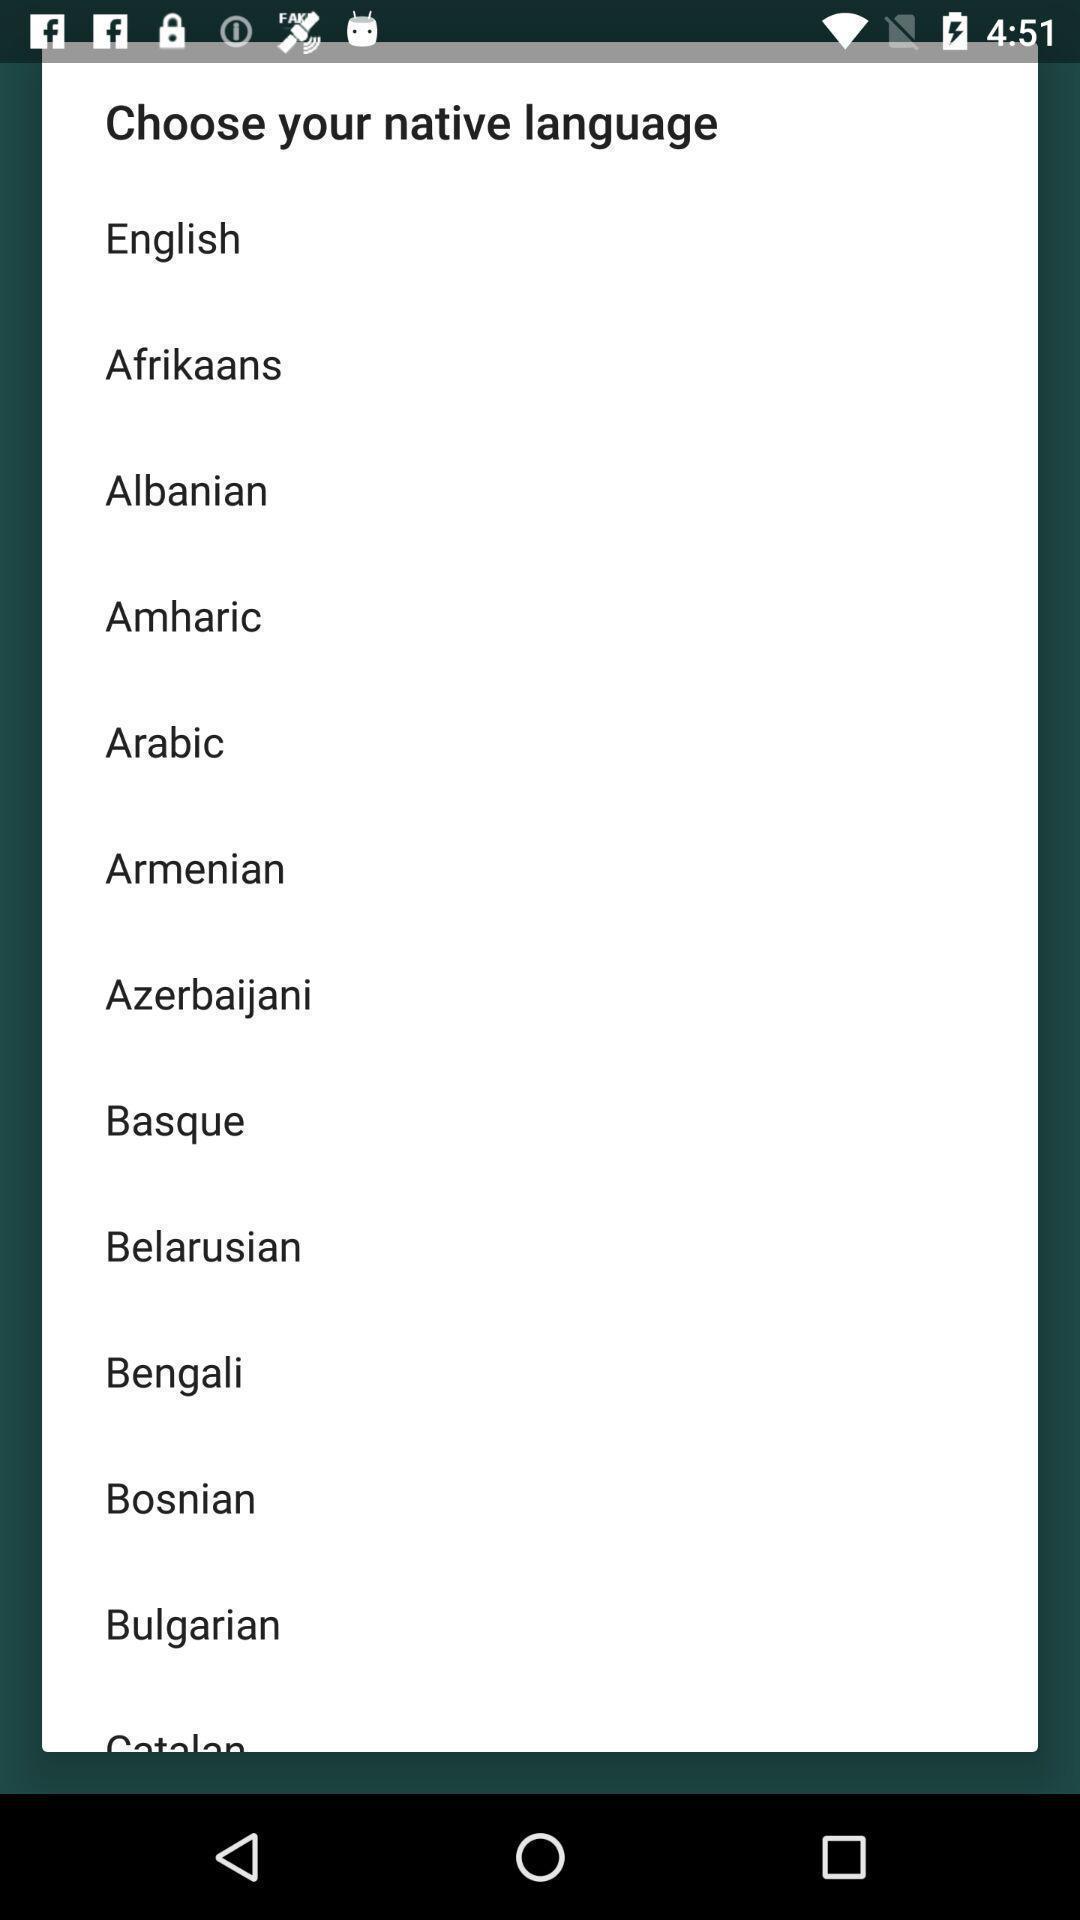Give me a summary of this screen capture. Pop-up with selection options in a language learning app. 